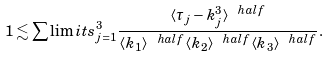<formula> <loc_0><loc_0><loc_500><loc_500>1 \lesssim \sum \lim i t s _ { j = 1 } ^ { 3 } \frac { \langle \tau _ { j } - k _ { j } ^ { 3 } \rangle ^ { \ h a l f } } { \langle k _ { 1 } \rangle ^ { \ h a l f } \langle k _ { 2 } \rangle ^ { \ h a l f } \langle k _ { 3 } \rangle ^ { \ h a l f } } .</formula> 